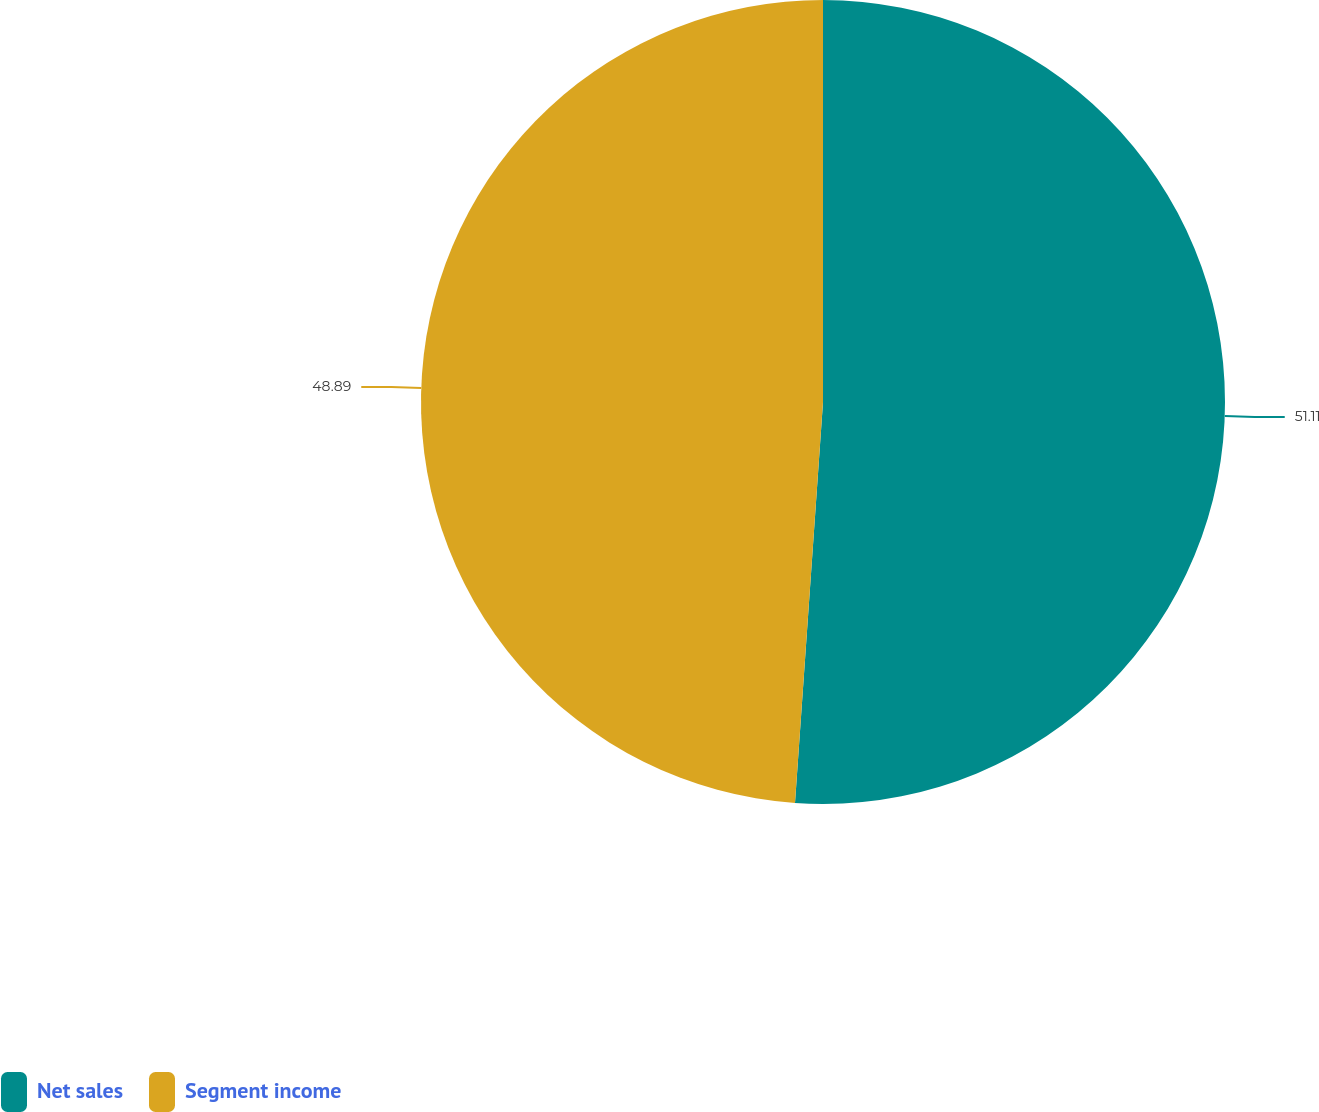<chart> <loc_0><loc_0><loc_500><loc_500><pie_chart><fcel>Net sales<fcel>Segment income<nl><fcel>51.11%<fcel>48.89%<nl></chart> 